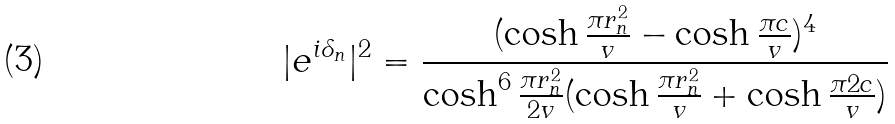Convert formula to latex. <formula><loc_0><loc_0><loc_500><loc_500>| e ^ { i \delta _ { n } } | ^ { 2 } = \frac { ( \cosh \frac { \pi r _ { n } ^ { 2 } } { v } - \cosh \frac { \pi c } { v } ) ^ { 4 } } { \cosh ^ { 6 } \frac { \pi r _ { n } ^ { 2 } } { 2 v } ( \cosh \frac { \pi r _ { n } ^ { 2 } } { v } + \cosh \frac { \pi 2 c } { v } ) }</formula> 